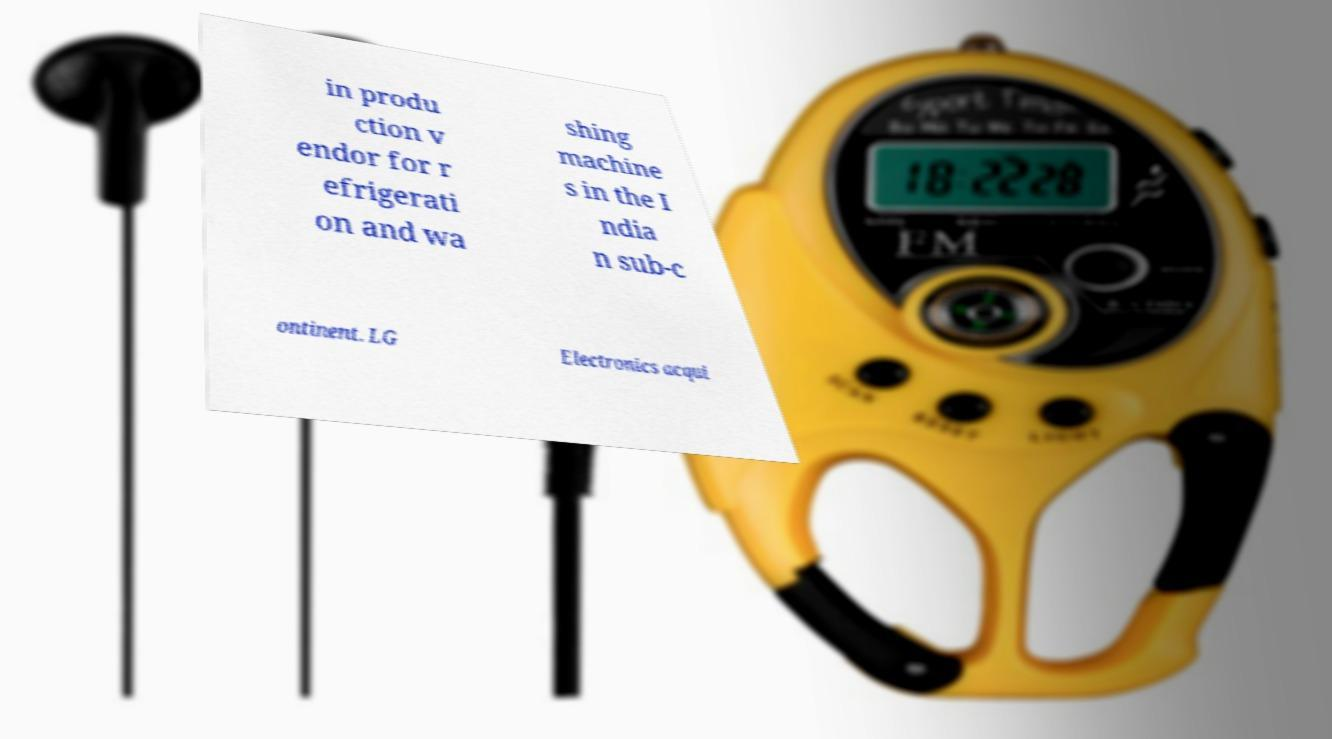Can you accurately transcribe the text from the provided image for me? in produ ction v endor for r efrigerati on and wa shing machine s in the I ndia n sub-c ontinent. LG Electronics acqui 